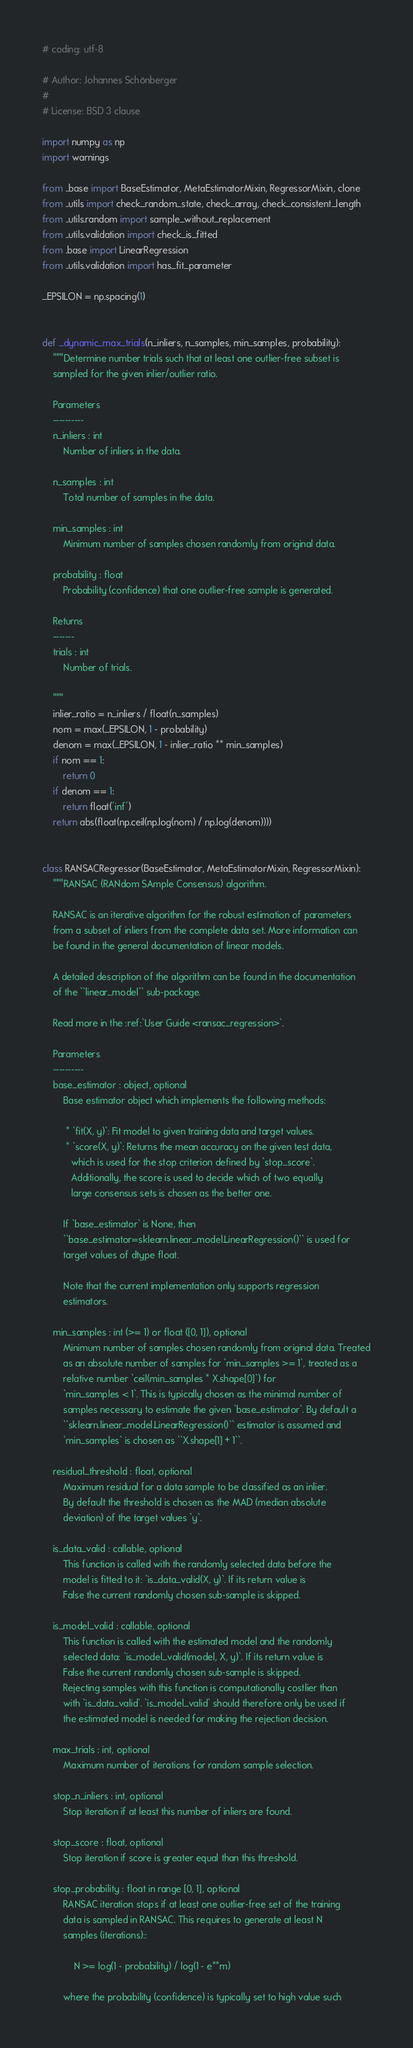<code> <loc_0><loc_0><loc_500><loc_500><_Python_># coding: utf-8

# Author: Johannes Schönberger
#
# License: BSD 3 clause

import numpy as np
import warnings

from ..base import BaseEstimator, MetaEstimatorMixin, RegressorMixin, clone
from ..utils import check_random_state, check_array, check_consistent_length
from ..utils.random import sample_without_replacement
from ..utils.validation import check_is_fitted
from .base import LinearRegression
from ..utils.validation import has_fit_parameter

_EPSILON = np.spacing(1)


def _dynamic_max_trials(n_inliers, n_samples, min_samples, probability):
    """Determine number trials such that at least one outlier-free subset is
    sampled for the given inlier/outlier ratio.

    Parameters
    ----------
    n_inliers : int
        Number of inliers in the data.

    n_samples : int
        Total number of samples in the data.

    min_samples : int
        Minimum number of samples chosen randomly from original data.

    probability : float
        Probability (confidence) that one outlier-free sample is generated.

    Returns
    -------
    trials : int
        Number of trials.

    """
    inlier_ratio = n_inliers / float(n_samples)
    nom = max(_EPSILON, 1 - probability)
    denom = max(_EPSILON, 1 - inlier_ratio ** min_samples)
    if nom == 1:
        return 0
    if denom == 1:
        return float('inf')
    return abs(float(np.ceil(np.log(nom) / np.log(denom))))


class RANSACRegressor(BaseEstimator, MetaEstimatorMixin, RegressorMixin):
    """RANSAC (RANdom SAmple Consensus) algorithm.

    RANSAC is an iterative algorithm for the robust estimation of parameters
    from a subset of inliers from the complete data set. More information can
    be found in the general documentation of linear models.

    A detailed description of the algorithm can be found in the documentation
    of the ``linear_model`` sub-package.

    Read more in the :ref:`User Guide <ransac_regression>`.

    Parameters
    ----------
    base_estimator : object, optional
        Base estimator object which implements the following methods:

         * `fit(X, y)`: Fit model to given training data and target values.
         * `score(X, y)`: Returns the mean accuracy on the given test data,
           which is used for the stop criterion defined by `stop_score`.
           Additionally, the score is used to decide which of two equally
           large consensus sets is chosen as the better one.

        If `base_estimator` is None, then
        ``base_estimator=sklearn.linear_model.LinearRegression()`` is used for
        target values of dtype float.

        Note that the current implementation only supports regression
        estimators.

    min_samples : int (>= 1) or float ([0, 1]), optional
        Minimum number of samples chosen randomly from original data. Treated
        as an absolute number of samples for `min_samples >= 1`, treated as a
        relative number `ceil(min_samples * X.shape[0]`) for
        `min_samples < 1`. This is typically chosen as the minimal number of
        samples necessary to estimate the given `base_estimator`. By default a
        ``sklearn.linear_model.LinearRegression()`` estimator is assumed and
        `min_samples` is chosen as ``X.shape[1] + 1``.

    residual_threshold : float, optional
        Maximum residual for a data sample to be classified as an inlier.
        By default the threshold is chosen as the MAD (median absolute
        deviation) of the target values `y`.

    is_data_valid : callable, optional
        This function is called with the randomly selected data before the
        model is fitted to it: `is_data_valid(X, y)`. If its return value is
        False the current randomly chosen sub-sample is skipped.

    is_model_valid : callable, optional
        This function is called with the estimated model and the randomly
        selected data: `is_model_valid(model, X, y)`. If its return value is
        False the current randomly chosen sub-sample is skipped.
        Rejecting samples with this function is computationally costlier than
        with `is_data_valid`. `is_model_valid` should therefore only be used if
        the estimated model is needed for making the rejection decision.

    max_trials : int, optional
        Maximum number of iterations for random sample selection.

    stop_n_inliers : int, optional
        Stop iteration if at least this number of inliers are found.

    stop_score : float, optional
        Stop iteration if score is greater equal than this threshold.

    stop_probability : float in range [0, 1], optional
        RANSAC iteration stops if at least one outlier-free set of the training
        data is sampled in RANSAC. This requires to generate at least N
        samples (iterations)::

            N >= log(1 - probability) / log(1 - e**m)

        where the probability (confidence) is typically set to high value such</code> 